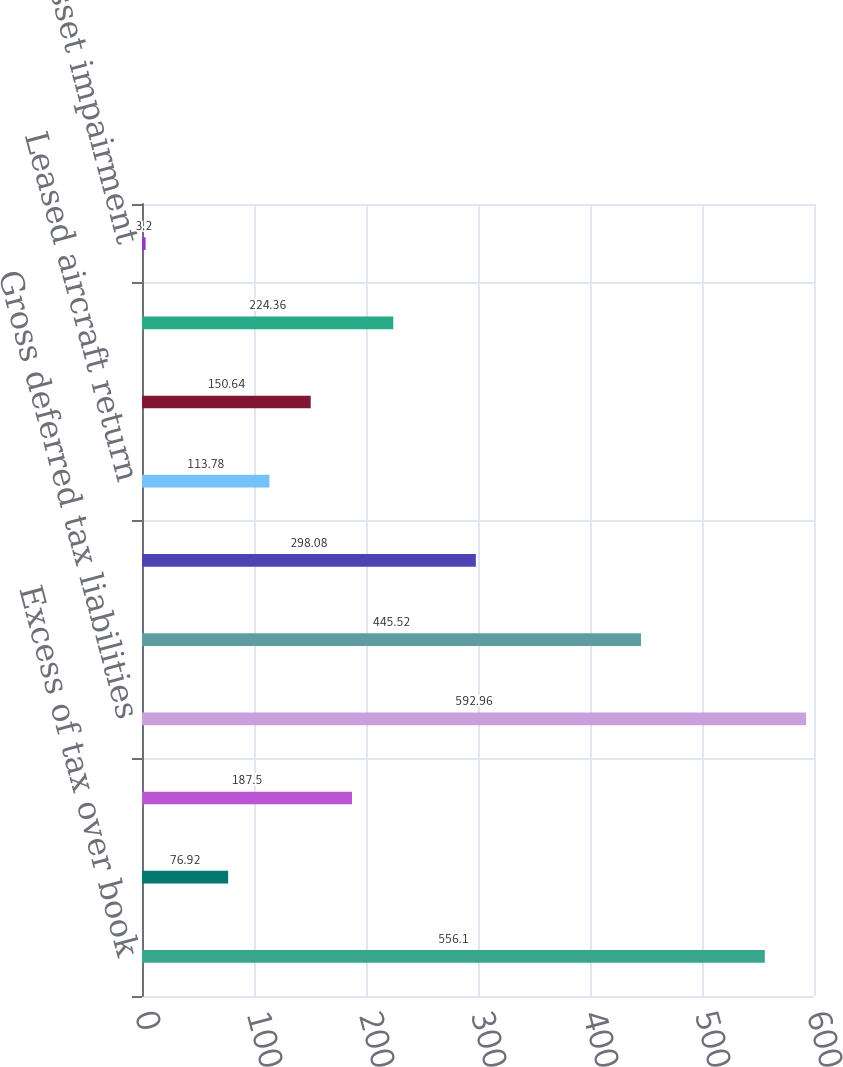<chart> <loc_0><loc_0><loc_500><loc_500><bar_chart><fcel>Excess of tax over book<fcel>Fuel hedges<fcel>Other - net<fcel>Gross deferred tax liabilities<fcel>Frequent flyer program<fcel>Alternative minimum tax<fcel>Leased aircraft return<fcel>Inventory obsolescence<fcel>Deferred revenue<fcel>Asset impairment<nl><fcel>556.1<fcel>76.92<fcel>187.5<fcel>592.96<fcel>445.52<fcel>298.08<fcel>113.78<fcel>150.64<fcel>224.36<fcel>3.2<nl></chart> 